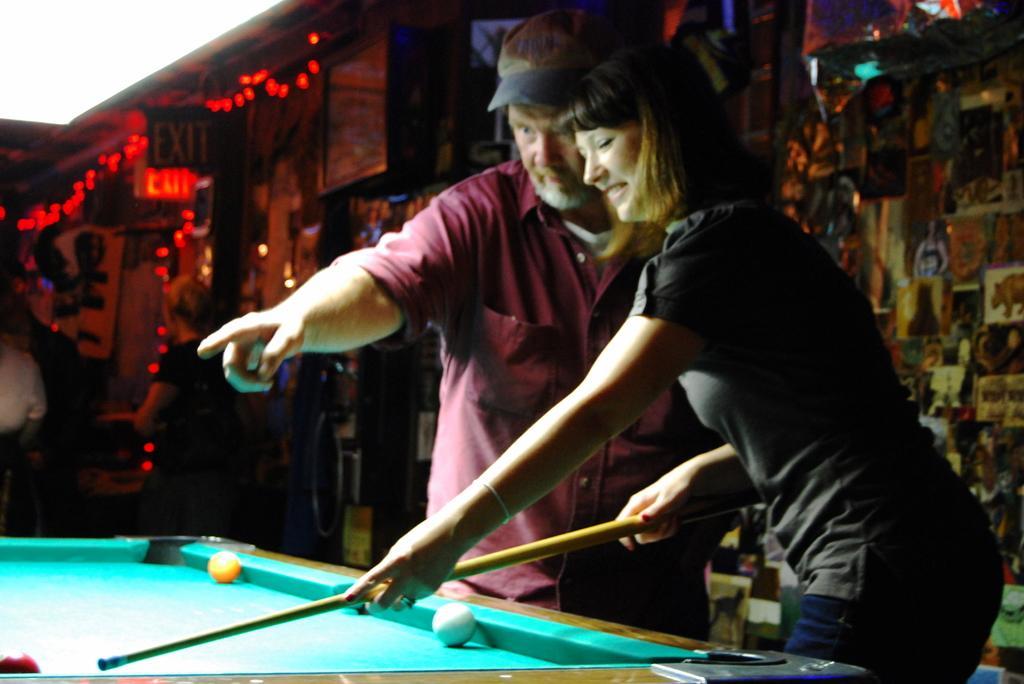Please provide a concise description of this image. On the background of the picture we can see a store with boards and lights. Here we can see one women is playing a snookers game by holding a stick in her hand. Here man wearing a cap guiding her. 